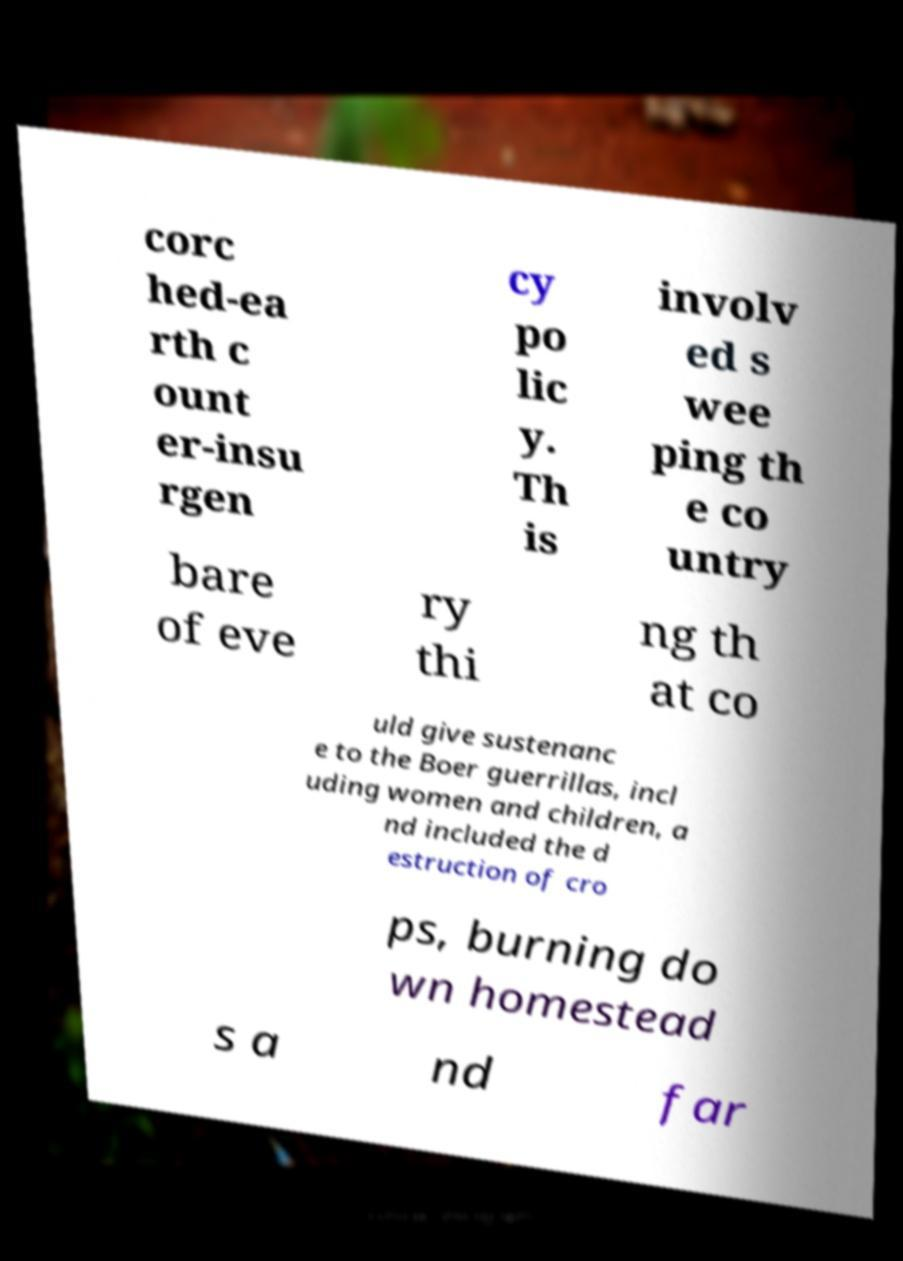What messages or text are displayed in this image? I need them in a readable, typed format. corc hed-ea rth c ount er-insu rgen cy po lic y. Th is involv ed s wee ping th e co untry bare of eve ry thi ng th at co uld give sustenanc e to the Boer guerrillas, incl uding women and children, a nd included the d estruction of cro ps, burning do wn homestead s a nd far 